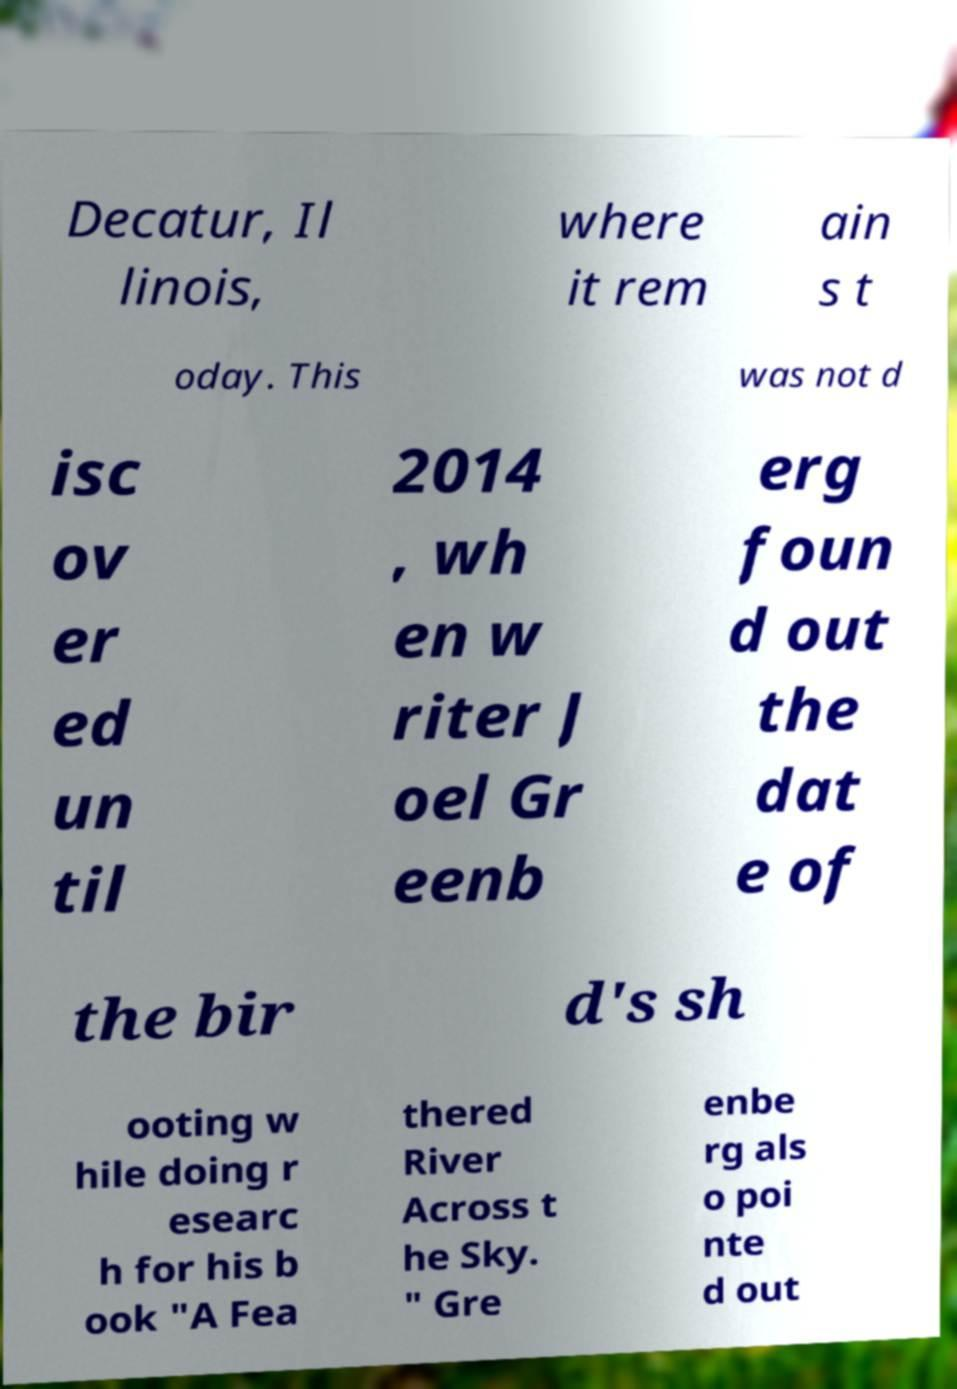There's text embedded in this image that I need extracted. Can you transcribe it verbatim? Decatur, Il linois, where it rem ain s t oday. This was not d isc ov er ed un til 2014 , wh en w riter J oel Gr eenb erg foun d out the dat e of the bir d's sh ooting w hile doing r esearc h for his b ook "A Fea thered River Across t he Sky. " Gre enbe rg als o poi nte d out 